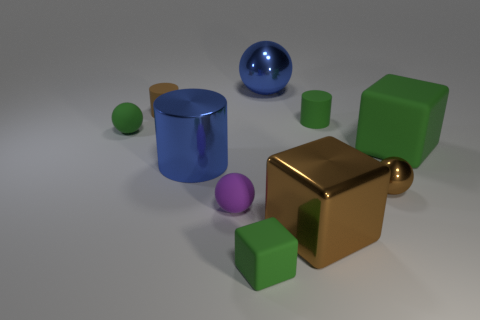Subtract all balls. How many objects are left? 6 Add 1 small blocks. How many small blocks are left? 2 Add 6 large cyan shiny objects. How many large cyan shiny objects exist? 6 Subtract 0 gray blocks. How many objects are left? 10 Subtract all tiny green shiny cylinders. Subtract all tiny purple things. How many objects are left? 9 